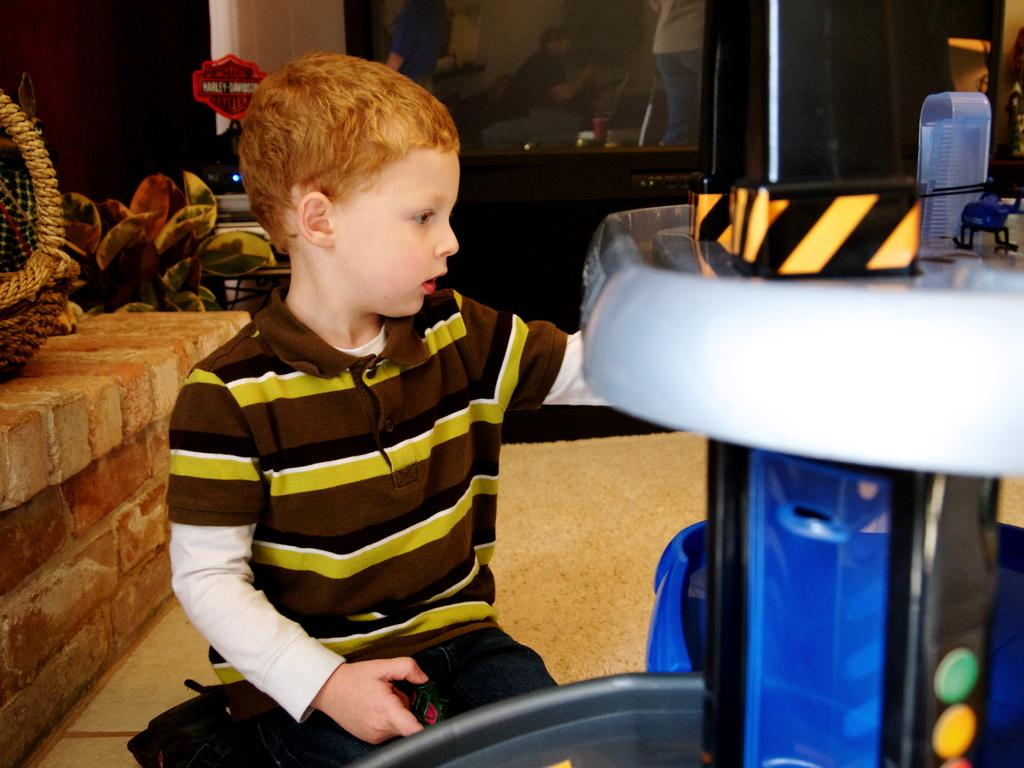What is the main subject in the image? There is a person in the image. Can you describe the object with white, blue, and black colors in the image? The object has buttons and is likely a device or clothing item. What can be seen in the background of the image? There is a black glass, a basket, leaves, and a brick wall in the background of the image. What type of rifle is the person holding in the image? There is no rifle present in the image; the person is not holding any weapon. Is there a writer in the image? The image does not show any indication of a writer or writing activity. 